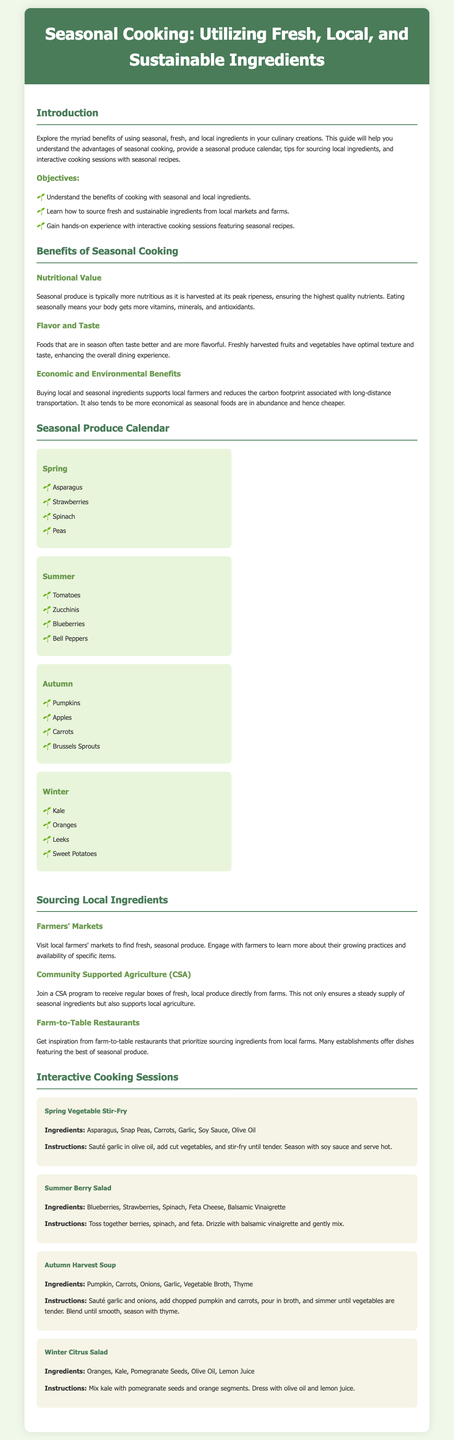What is the title of the lesson plan? The title is prominently displayed in the header of the document.
Answer: Seasonal Cooking: Utilizing Fresh, Local, and Sustainable Ingredients What is one benefit of seasonal cooking mentioned in the document? Benefits are listed under the section titled "Benefits of Seasonal Cooking".
Answer: Nutritional Value Which season includes asparagus in the seasonal produce calendar? Asparagus is listed under the Spring section in the seasonal calendar.
Answer: Spring How many interactive cooking sessions are described in the document? The document explains four different seasonal recipes that correspond with the interactive cooking sessions.
Answer: Four What type of agriculture program can provide regular boxes of fresh produce? This is mentioned under the sourcing local ingredients section.
Answer: Community Supported Agriculture (CSA) Which two ingredients are used in the Summer Berry Salad recipe? The ingredients are included alongside the recipe instructions.
Answer: Blueberries, Strawberries What season includes pumpkins according to the seasonal produce calendar? Pumpkins are specifically noted under the Autumn section of the calendar.
Answer: Autumn What should be sautéed first in the Autumn Harvest Soup? The cooking instructions outline the first step very clearly.
Answer: Garlic and onions 